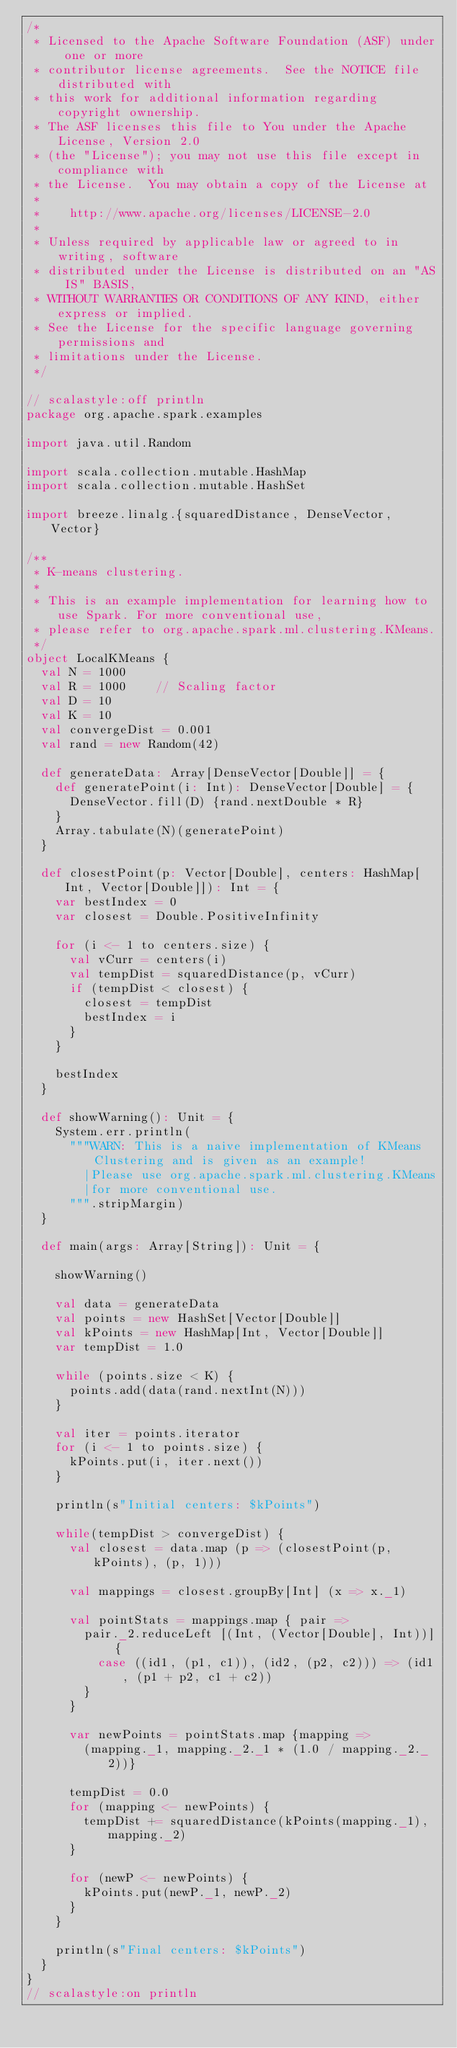<code> <loc_0><loc_0><loc_500><loc_500><_Scala_>/*
 * Licensed to the Apache Software Foundation (ASF) under one or more
 * contributor license agreements.  See the NOTICE file distributed with
 * this work for additional information regarding copyright ownership.
 * The ASF licenses this file to You under the Apache License, Version 2.0
 * (the "License"); you may not use this file except in compliance with
 * the License.  You may obtain a copy of the License at
 *
 *    http://www.apache.org/licenses/LICENSE-2.0
 *
 * Unless required by applicable law or agreed to in writing, software
 * distributed under the License is distributed on an "AS IS" BASIS,
 * WITHOUT WARRANTIES OR CONDITIONS OF ANY KIND, either express or implied.
 * See the License for the specific language governing permissions and
 * limitations under the License.
 */

// scalastyle:off println
package org.apache.spark.examples

import java.util.Random

import scala.collection.mutable.HashMap
import scala.collection.mutable.HashSet

import breeze.linalg.{squaredDistance, DenseVector, Vector}

/**
 * K-means clustering.
 *
 * This is an example implementation for learning how to use Spark. For more conventional use,
 * please refer to org.apache.spark.ml.clustering.KMeans.
 */
object LocalKMeans {
  val N = 1000
  val R = 1000    // Scaling factor
  val D = 10
  val K = 10
  val convergeDist = 0.001
  val rand = new Random(42)

  def generateData: Array[DenseVector[Double]] = {
    def generatePoint(i: Int): DenseVector[Double] = {
      DenseVector.fill(D) {rand.nextDouble * R}
    }
    Array.tabulate(N)(generatePoint)
  }

  def closestPoint(p: Vector[Double], centers: HashMap[Int, Vector[Double]]): Int = {
    var bestIndex = 0
    var closest = Double.PositiveInfinity

    for (i <- 1 to centers.size) {
      val vCurr = centers(i)
      val tempDist = squaredDistance(p, vCurr)
      if (tempDist < closest) {
        closest = tempDist
        bestIndex = i
      }
    }

    bestIndex
  }

  def showWarning(): Unit = {
    System.err.println(
      """WARN: This is a naive implementation of KMeans Clustering and is given as an example!
        |Please use org.apache.spark.ml.clustering.KMeans
        |for more conventional use.
      """.stripMargin)
  }

  def main(args: Array[String]): Unit = {

    showWarning()

    val data = generateData
    val points = new HashSet[Vector[Double]]
    val kPoints = new HashMap[Int, Vector[Double]]
    var tempDist = 1.0

    while (points.size < K) {
      points.add(data(rand.nextInt(N)))
    }

    val iter = points.iterator
    for (i <- 1 to points.size) {
      kPoints.put(i, iter.next())
    }

    println(s"Initial centers: $kPoints")

    while(tempDist > convergeDist) {
      val closest = data.map (p => (closestPoint(p, kPoints), (p, 1)))

      val mappings = closest.groupBy[Int] (x => x._1)

      val pointStats = mappings.map { pair =>
        pair._2.reduceLeft [(Int, (Vector[Double], Int))] {
          case ((id1, (p1, c1)), (id2, (p2, c2))) => (id1, (p1 + p2, c1 + c2))
        }
      }

      var newPoints = pointStats.map {mapping =>
        (mapping._1, mapping._2._1 * (1.0 / mapping._2._2))}

      tempDist = 0.0
      for (mapping <- newPoints) {
        tempDist += squaredDistance(kPoints(mapping._1), mapping._2)
      }

      for (newP <- newPoints) {
        kPoints.put(newP._1, newP._2)
      }
    }

    println(s"Final centers: $kPoints")
  }
}
// scalastyle:on println
</code> 